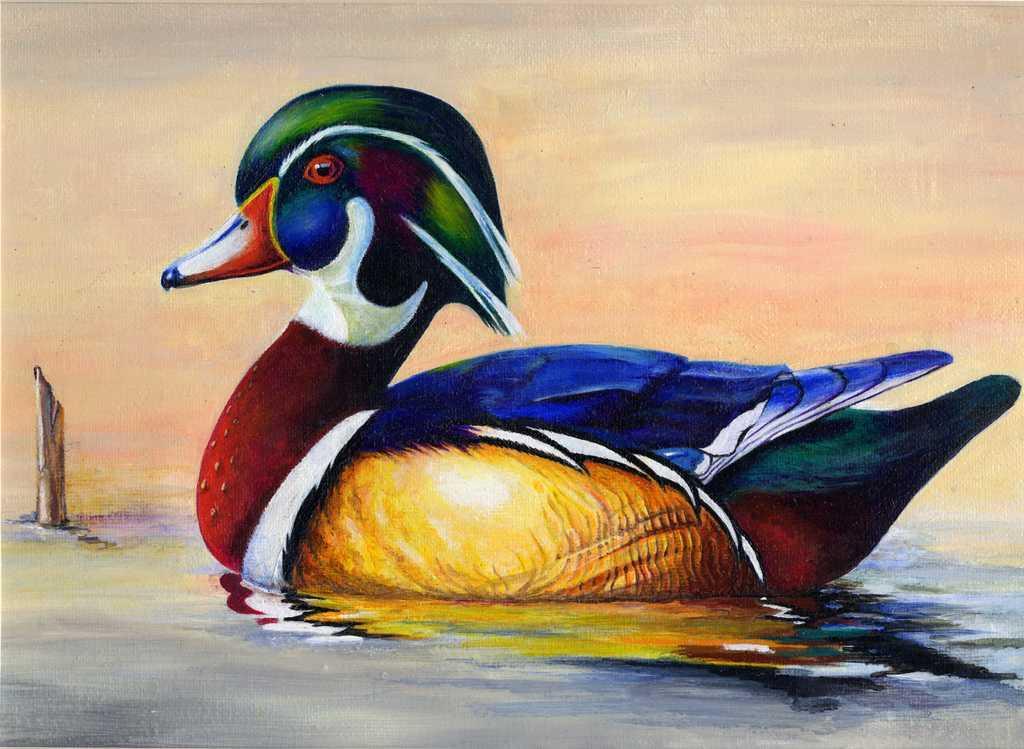Could you give a brief overview of what you see in this image? This is a painting of a duck in the water. 